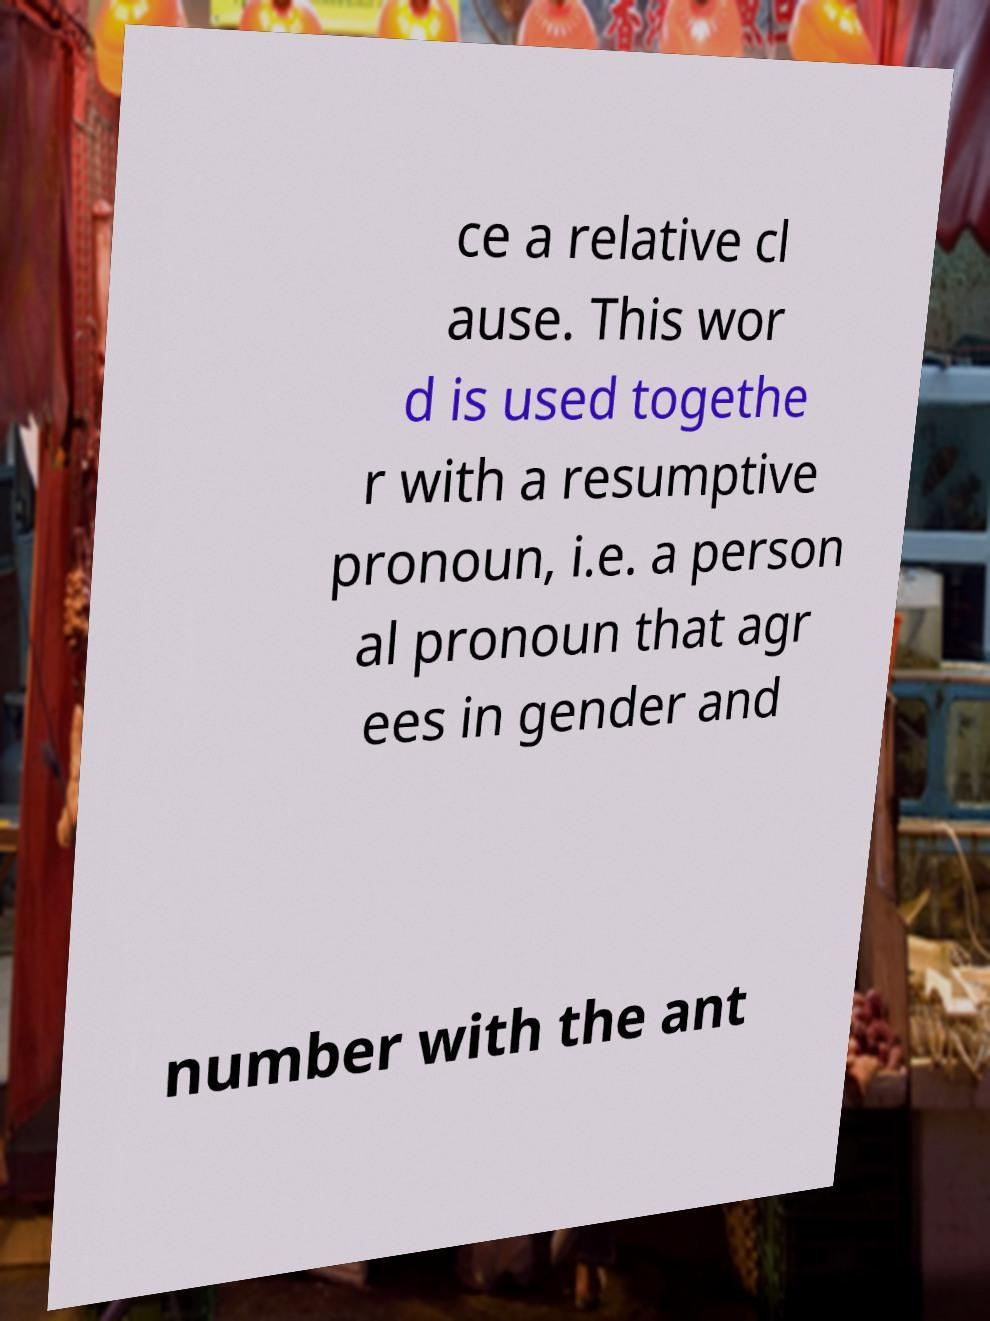Please read and relay the text visible in this image. What does it say? ce a relative cl ause. This wor d is used togethe r with a resumptive pronoun, i.e. a person al pronoun that agr ees in gender and number with the ant 